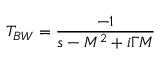<formula> <loc_0><loc_0><loc_500><loc_500>T _ { B W } = { \frac { - 1 } { s - M ^ { 2 } + i \Gamma M } }</formula> 